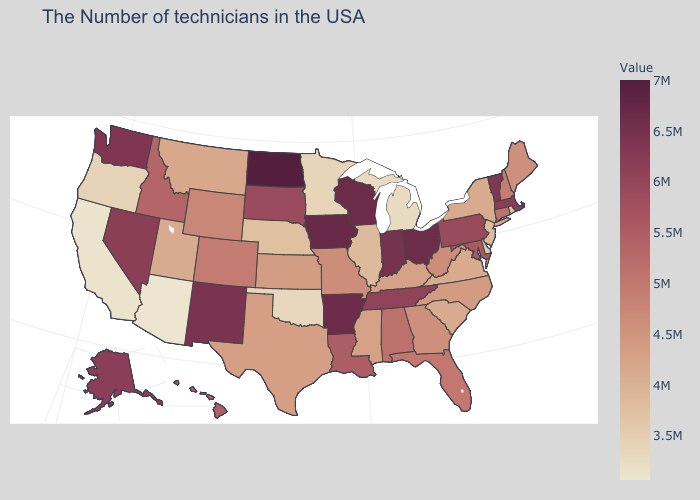Which states have the lowest value in the USA?
Answer briefly. Arizona. Does the map have missing data?
Short answer required. No. Which states have the lowest value in the USA?
Be succinct. Arizona. Is the legend a continuous bar?
Answer briefly. Yes. Among the states that border Vermont , does New Hampshire have the highest value?
Keep it brief. No. Does Idaho have a higher value than South Carolina?
Be succinct. Yes. Which states hav the highest value in the Northeast?
Answer briefly. Vermont. 